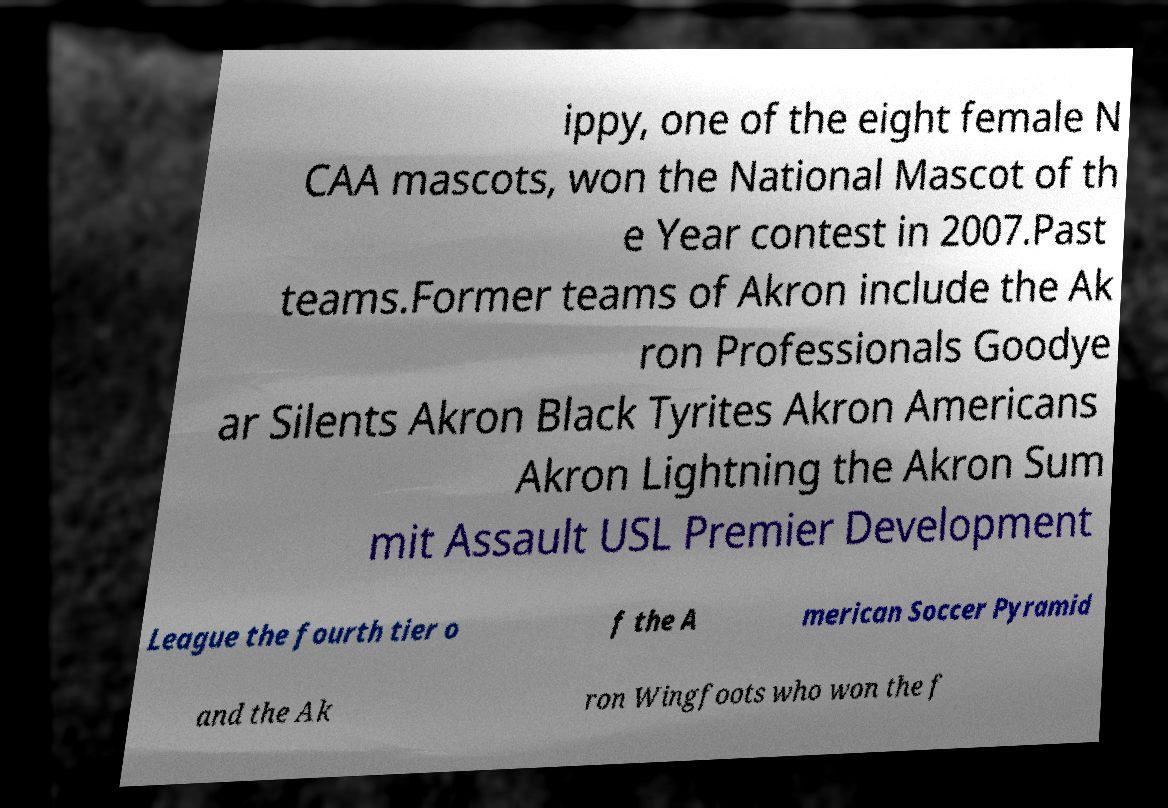What messages or text are displayed in this image? I need them in a readable, typed format. ippy, one of the eight female N CAA mascots, won the National Mascot of th e Year contest in 2007.Past teams.Former teams of Akron include the Ak ron Professionals Goodye ar Silents Akron Black Tyrites Akron Americans Akron Lightning the Akron Sum mit Assault USL Premier Development League the fourth tier o f the A merican Soccer Pyramid and the Ak ron Wingfoots who won the f 